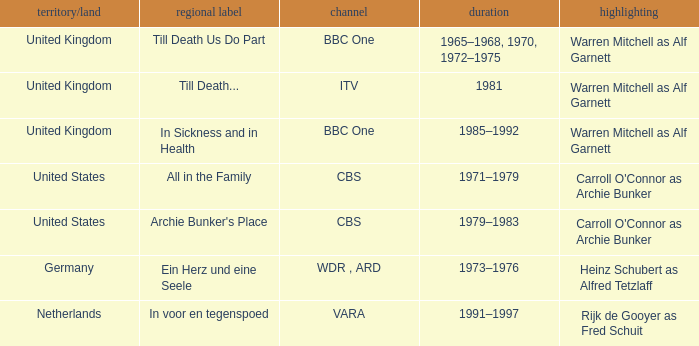What is the name of the network in the United Kingdom which aired in 1985–1992? BBC One. 